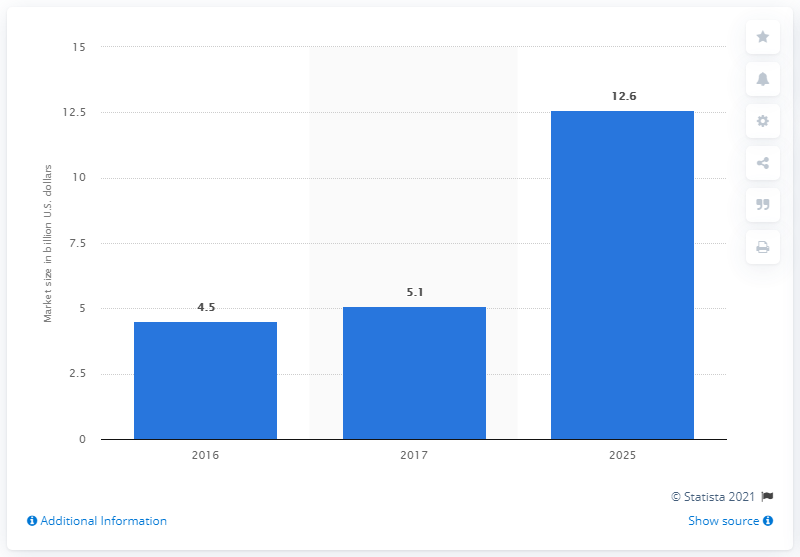Point out several critical features in this image. The market size for surgical robots is estimated to be 12.6 billion US dollars in 2025. 